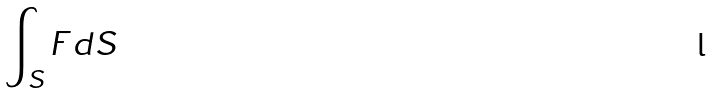<formula> <loc_0><loc_0><loc_500><loc_500>\int _ { S } F d S</formula> 